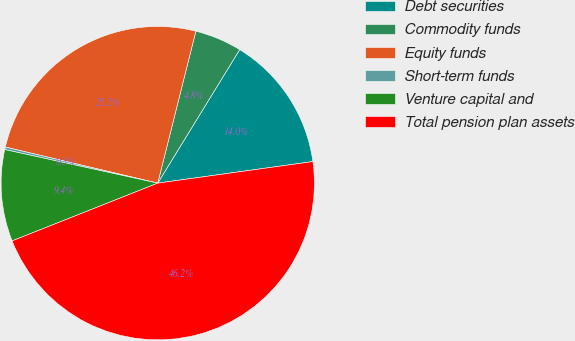<chart> <loc_0><loc_0><loc_500><loc_500><pie_chart><fcel>Debt securities<fcel>Commodity funds<fcel>Equity funds<fcel>Short-term funds<fcel>Venture capital and<fcel>Total pension plan assets<nl><fcel>14.04%<fcel>4.85%<fcel>25.21%<fcel>0.26%<fcel>9.45%<fcel>46.19%<nl></chart> 